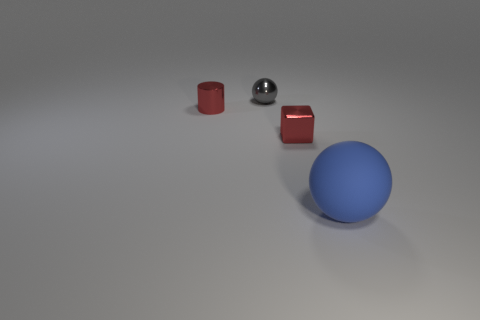Add 1 small yellow rubber balls. How many objects exist? 5 Subtract all blue balls. How many balls are left? 1 Subtract all blocks. How many objects are left? 3 Subtract 1 blocks. How many blocks are left? 0 Add 2 blue rubber objects. How many blue rubber objects are left? 3 Add 4 big rubber balls. How many big rubber balls exist? 5 Subtract 0 cyan cylinders. How many objects are left? 4 Subtract all gray blocks. Subtract all red spheres. How many blocks are left? 1 Subtract all large matte things. Subtract all blue rubber balls. How many objects are left? 2 